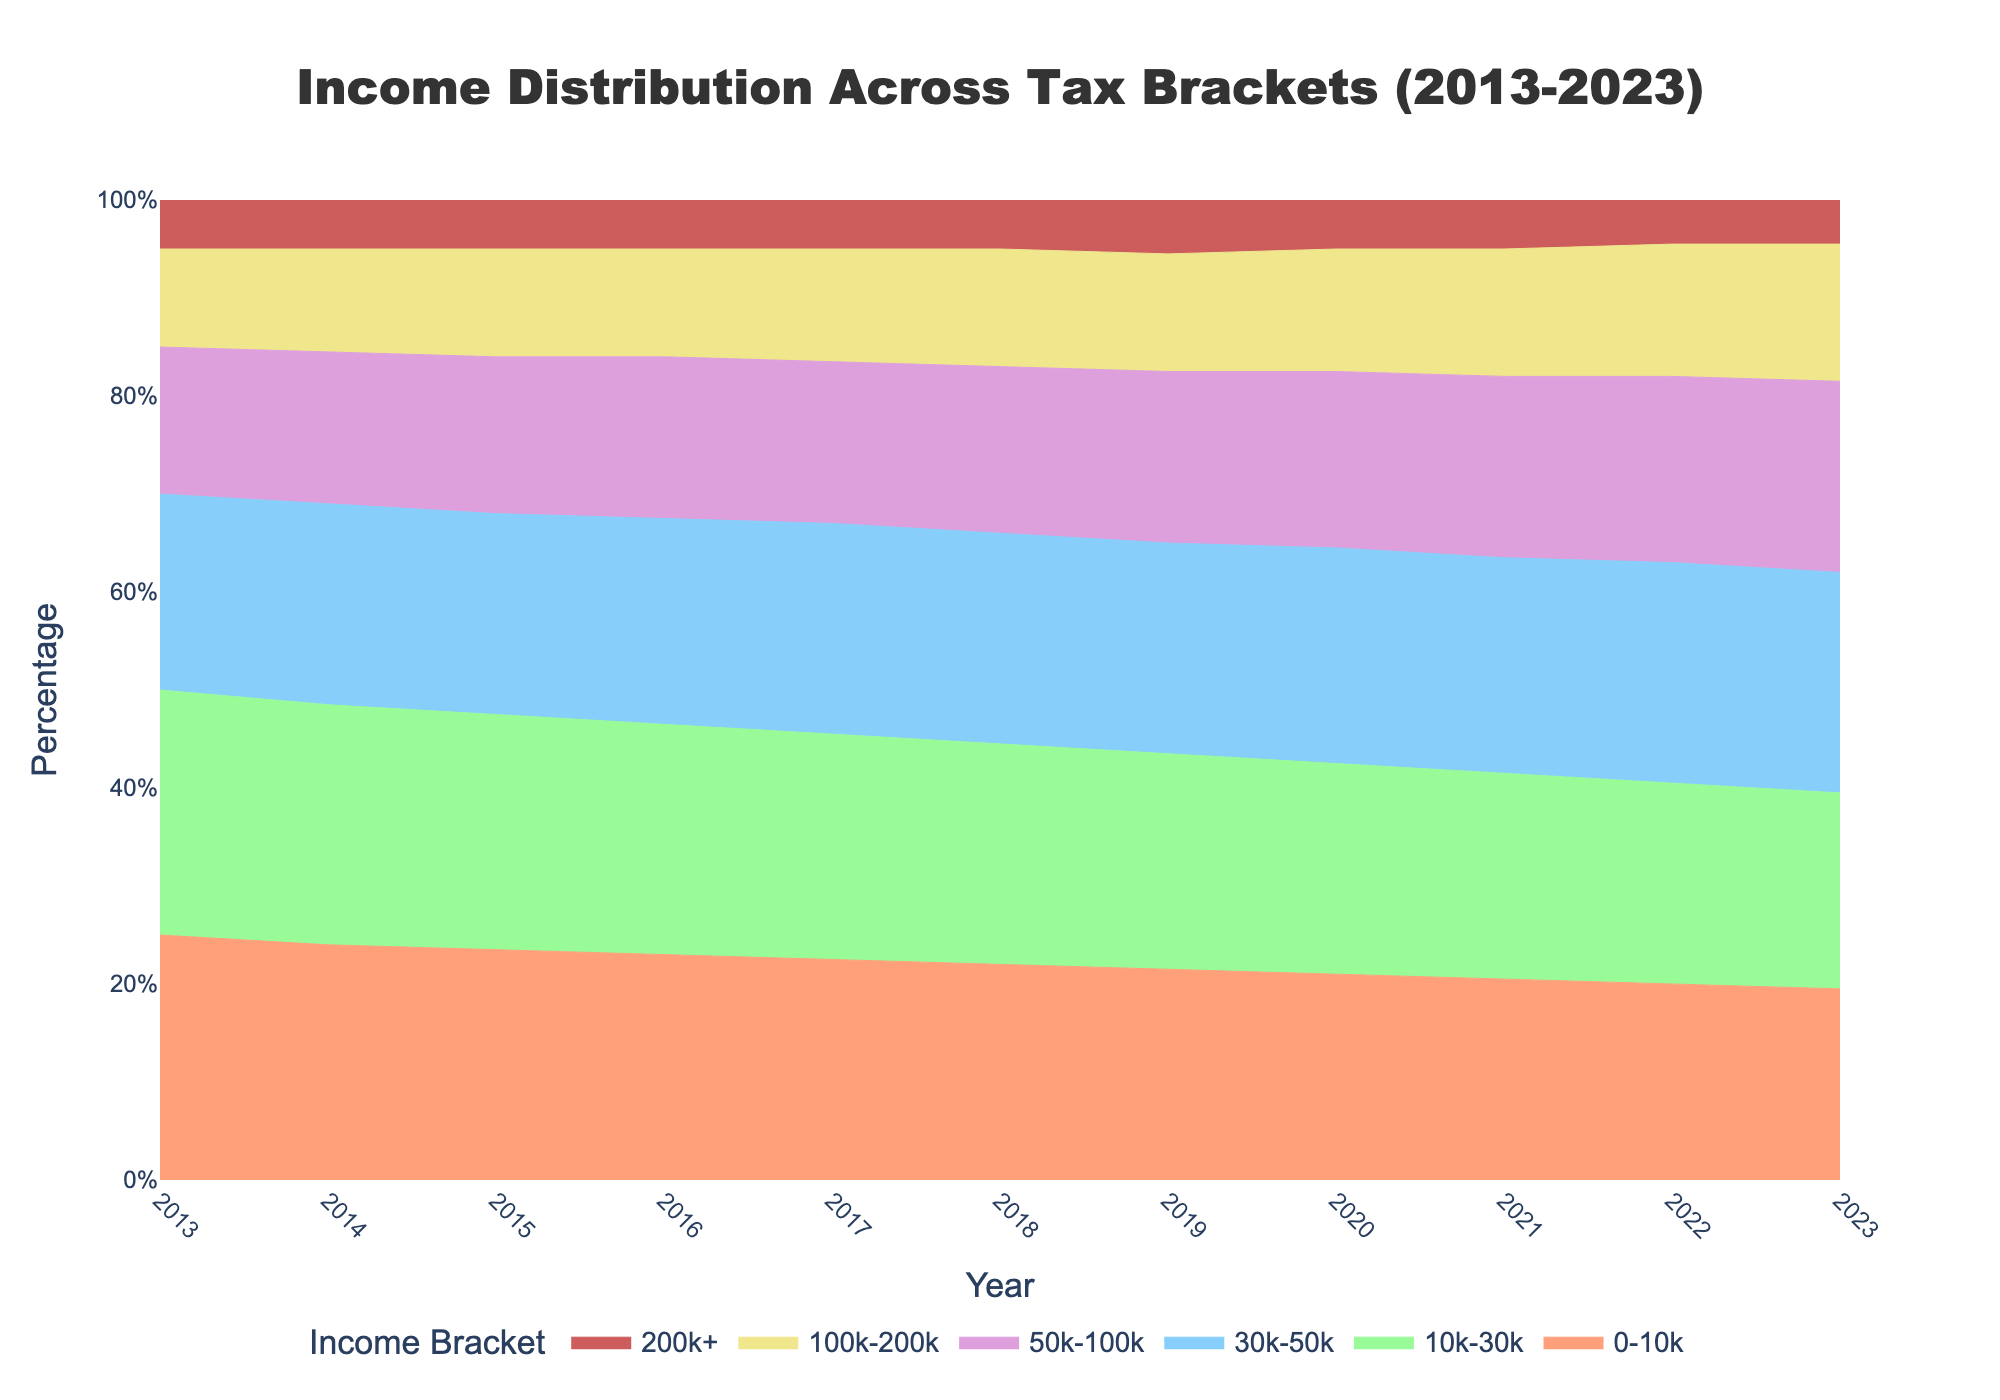What is the title of the chart? The title of the chart is displayed at the top and reads "Income Distribution Across Tax Brackets (2013-2023)."
Answer: Income Distribution Across Tax Brackets (2013-2023) Which income bracket had the highest percentage in 2013? By looking at the areas stacked in the chart for the year 2013, the 0-10k income bracket has the largest area.
Answer: 0-10k How does the 10k-30k bracket's percentage change from 2013 to 2023? First, identify the percentage for the 10k-30k bracket in both 2013 and 2023 from the chart. In 2013 it is 25%, and in 2023 it is 20%. Calculate the change: 20% - 25% = -5%.
Answer: -5% Which two income brackets had equal percentages in 2017? By checking the proportions for each income bracket in 2017, the 10k-30k and 30k-50k income brackets both have percentages very close to 23% and 21.5%, respectively. Determine which pairs match.
Answer: None In which year did the 100k-200k income bracket first exceed 12%? Check each year starting from 2013 to find when the 100k-200k bracket first goes over 12% by observing the graphical proportions. In 2018, the percentage exceeded 12% for the first time.
Answer: 2018 By how many percentage points did the 30k-50k bracket's share increase from 2013 to 2023? Identify the percentage for the 30k-50k bracket in both 2013 and 2023 from the chart. In 2013 it is 20%, and in 2023 it is 22.5%. The increase is calculated as 22.5% - 20% = 2.5%.
Answer: 2.5% Which income bracket experienced the greatest decrease in percentage from 2013 to 2023? By examining the chart, observe the percentage change for each income bracket from 2013 to 2023. The 0-10k bracket decreases from 25% to 19.5%, the largest drop of 5.5%.
Answer: 0-10k What is the total percentage of the top two income brackets combined in 2020? For 2020, add the percentages of the 100k-200k and 200k+ brackets. The values are 12.5% (100k-200k) and 5% (200k+), so their total is 12.5% + 5% = 17.5%.
Answer: 17.5% Did any income bracket's percentage remain constant throughout the decade? By scanning the chart for each year from 2013 to 2023, check if any income bracket's percentage remains unchanged. The 200k+ bracket consistently stays around 5%.
Answer: No 